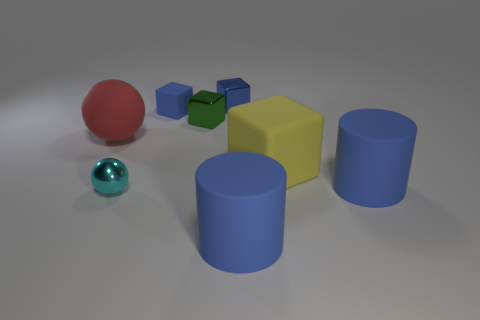What might the spatial arrangement of these objects signify? The spatial arrangement appears to be intentionally structured, with objects placed at varying distances from one another, possibly implying an exploratory study of geometry, color contrasts, and the interplay of light and texture in an artificial environment. This setup might be used to demonstrate concepts in visual design or to create an aesthetically pleasing 3D composition. Could there be a functional purpose behind their arrangement? If we were to speculate, the arrangement might similarly be used in an educational context to teach sorting or categorization based on shape and color, or perhaps to demonstrate concepts in physics like the reflection and absorption of light on different surfaces. 